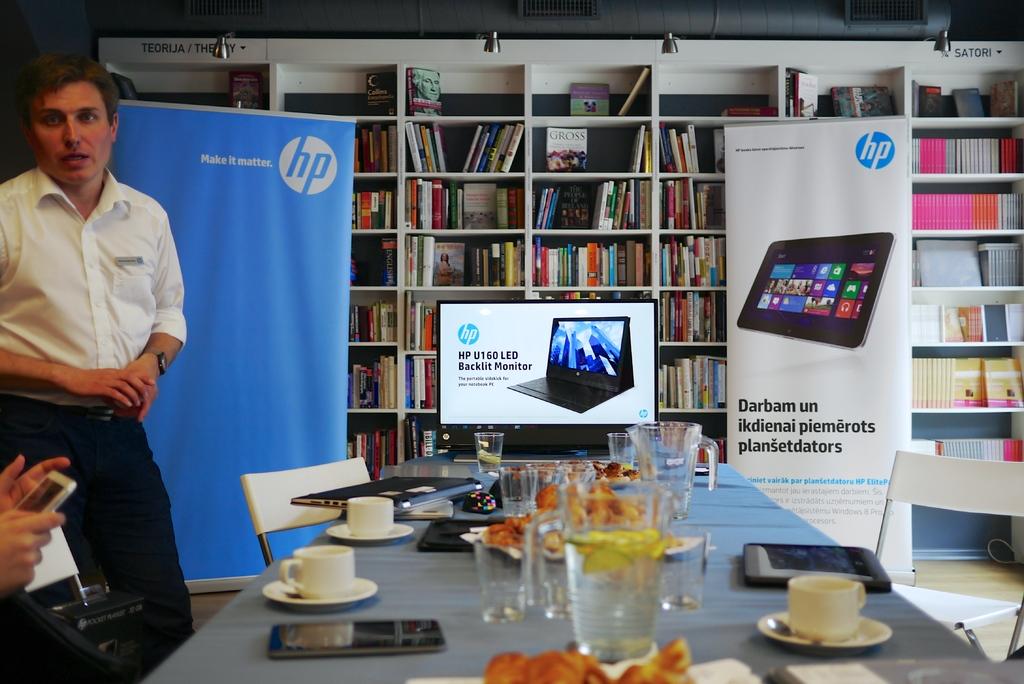What are they promoting?
Provide a succinct answer. Hp. Who is the manufacturer?
Offer a terse response. Hp. 